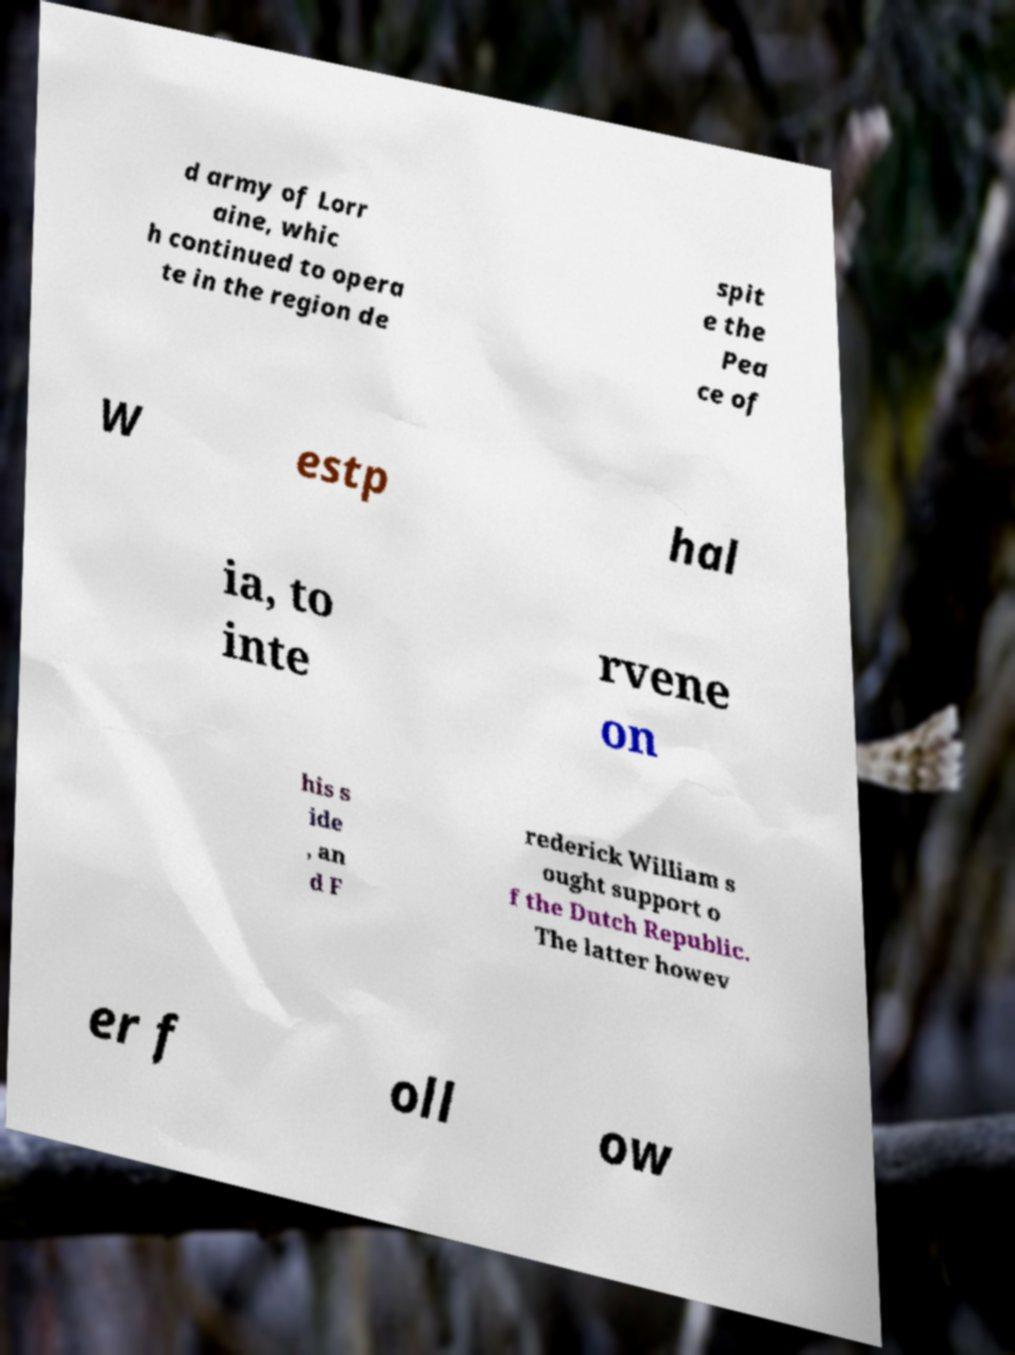There's text embedded in this image that I need extracted. Can you transcribe it verbatim? d army of Lorr aine, whic h continued to opera te in the region de spit e the Pea ce of W estp hal ia, to inte rvene on his s ide , an d F rederick William s ought support o f the Dutch Republic. The latter howev er f oll ow 